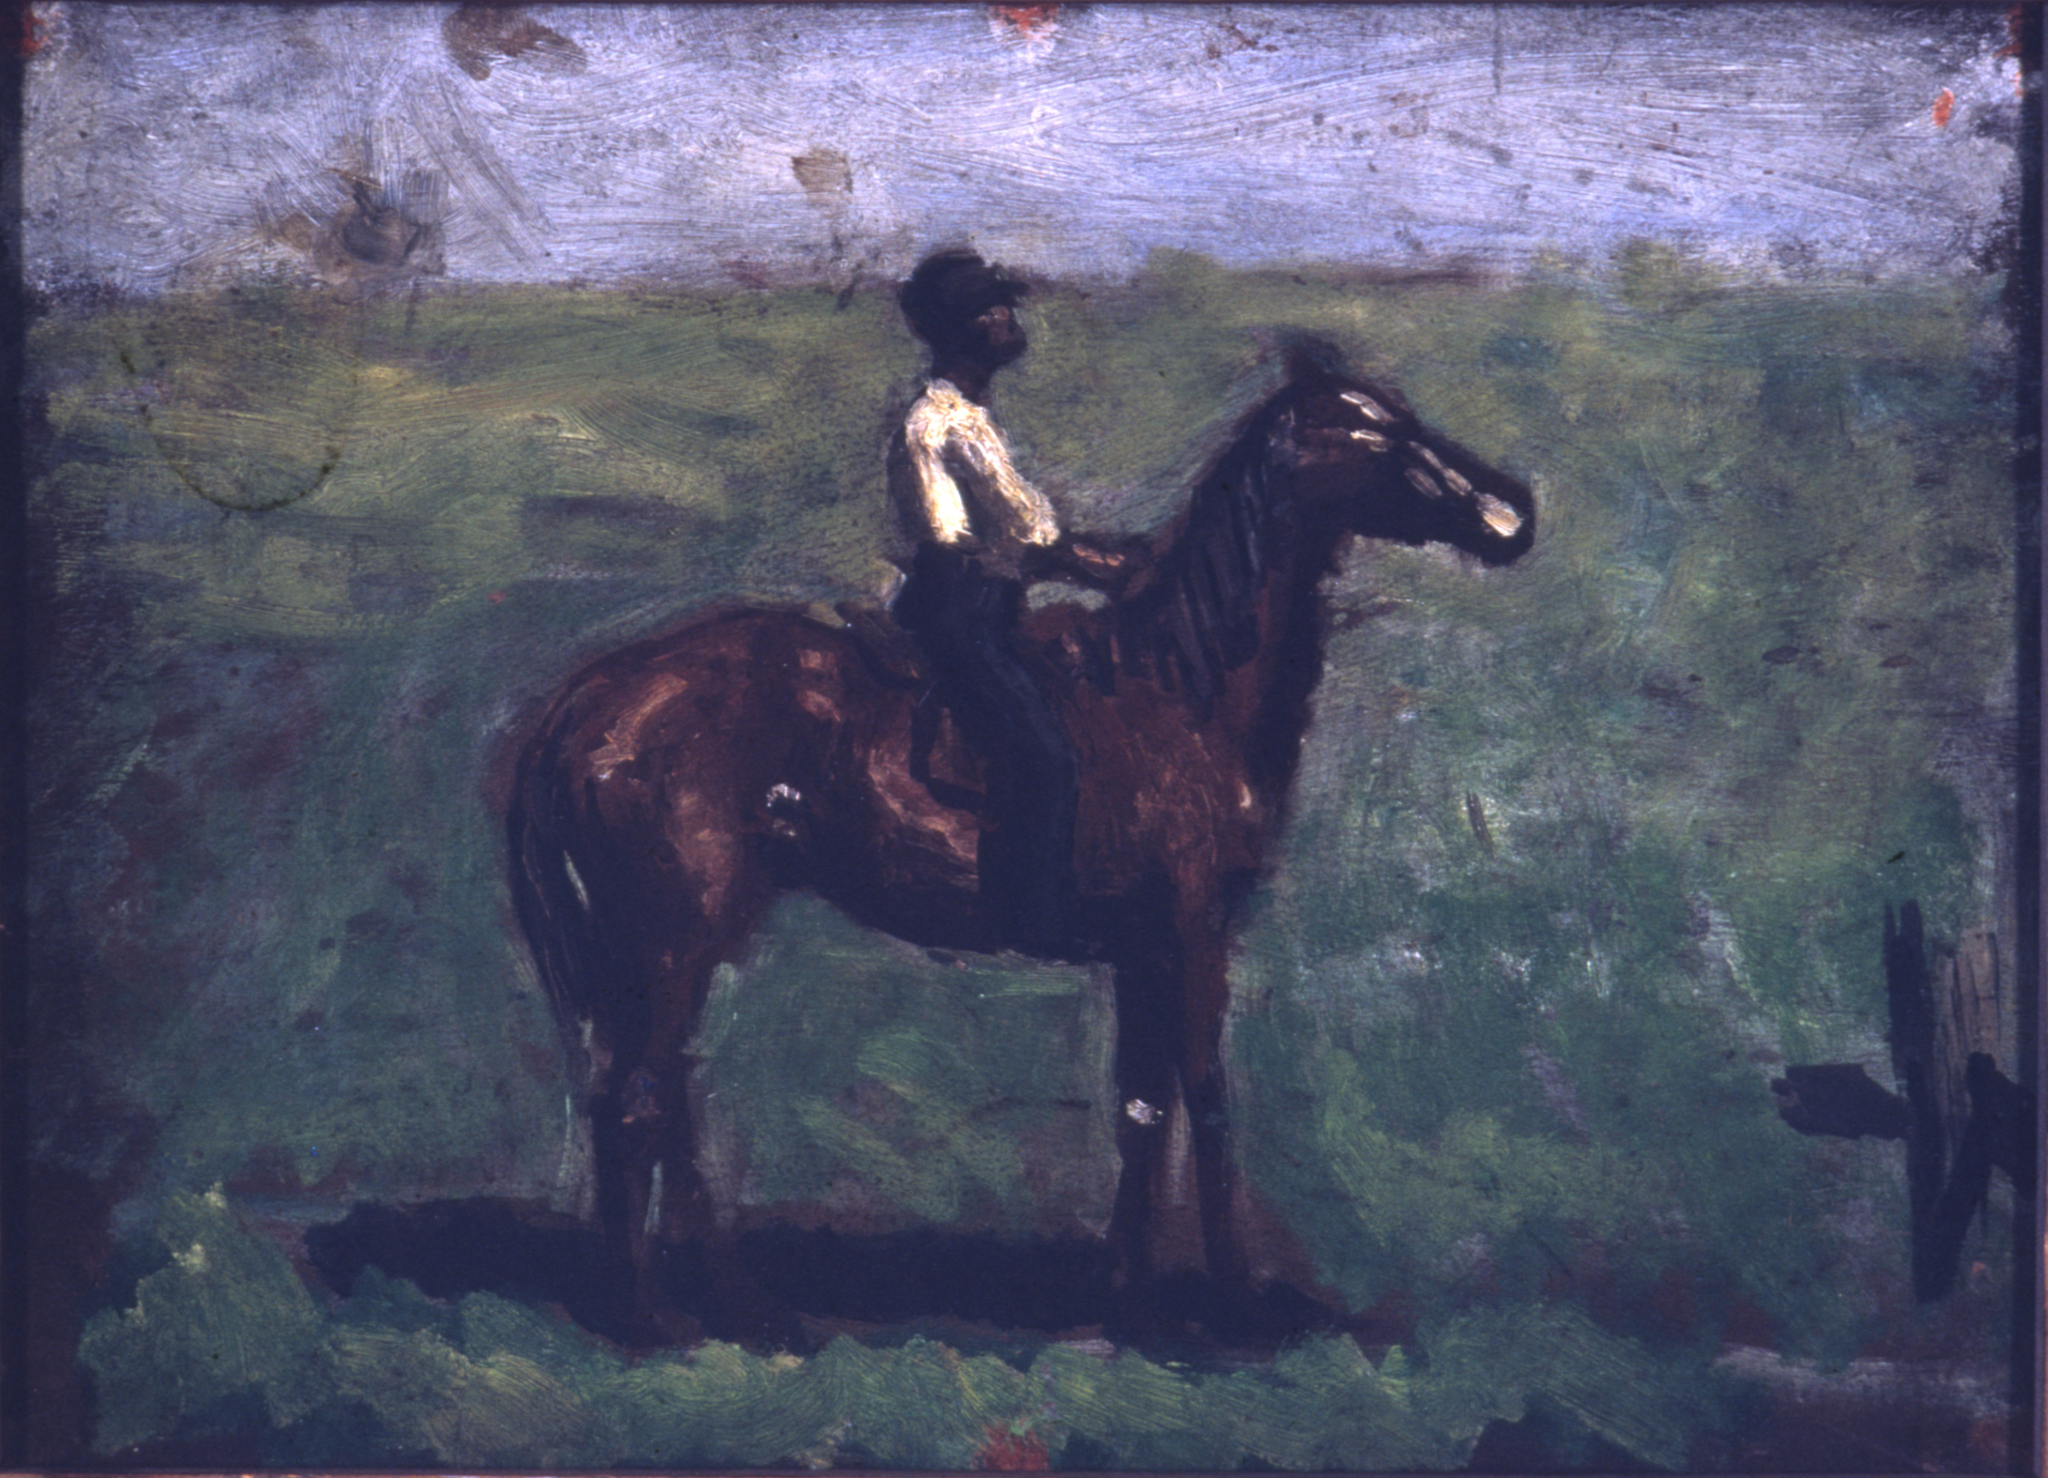Can you give a short, creative story involving the landscape in the painting? One morning, as the first light of dawn kissed the landscape, a mystical fog rolled over the meadows. Unbeknownst to the villagers, within the fog lay hidden doorways to enchanted worlds. The rider, feeling a pull in his heart, guided Noire through the mist. They emerged into a realm where colors seemed brighter, and animals spoke in riddles. The rider soon found himself on a quest to find a fabled artifact said to bring prosperity to any land. Along the way, he solved puzzles presented by wise old trees, and befriended creatures of all sorts. The journey transformed him, and when he returned through the fog, the village could sense a change — a promise of good fortune on the horizon. 